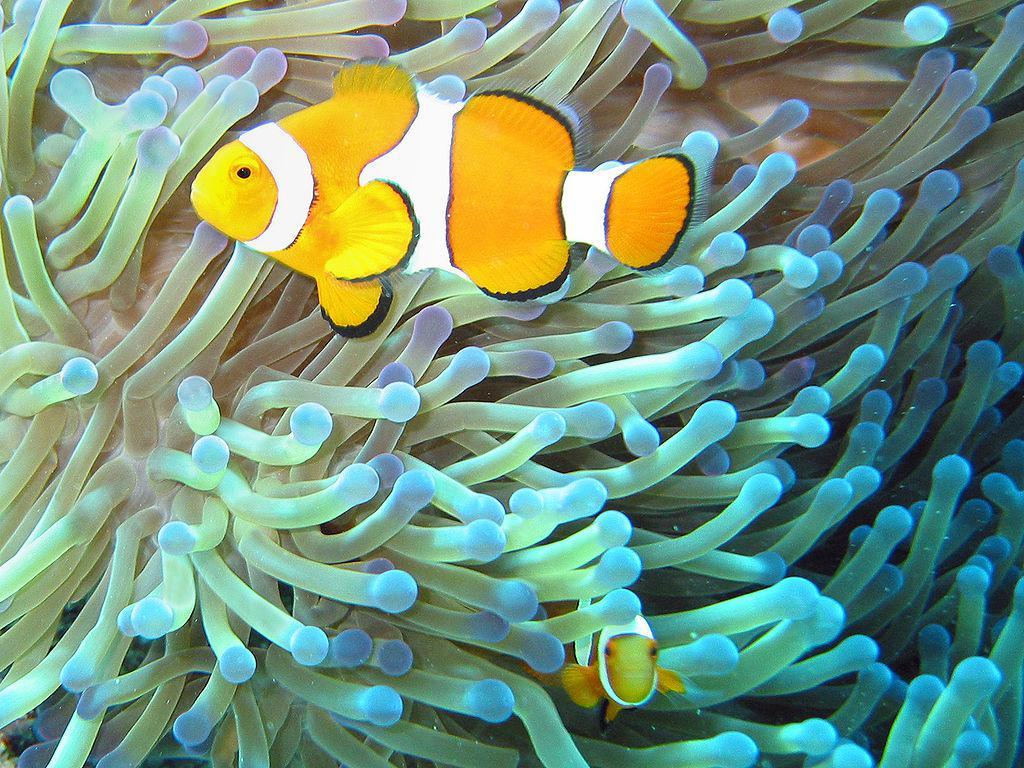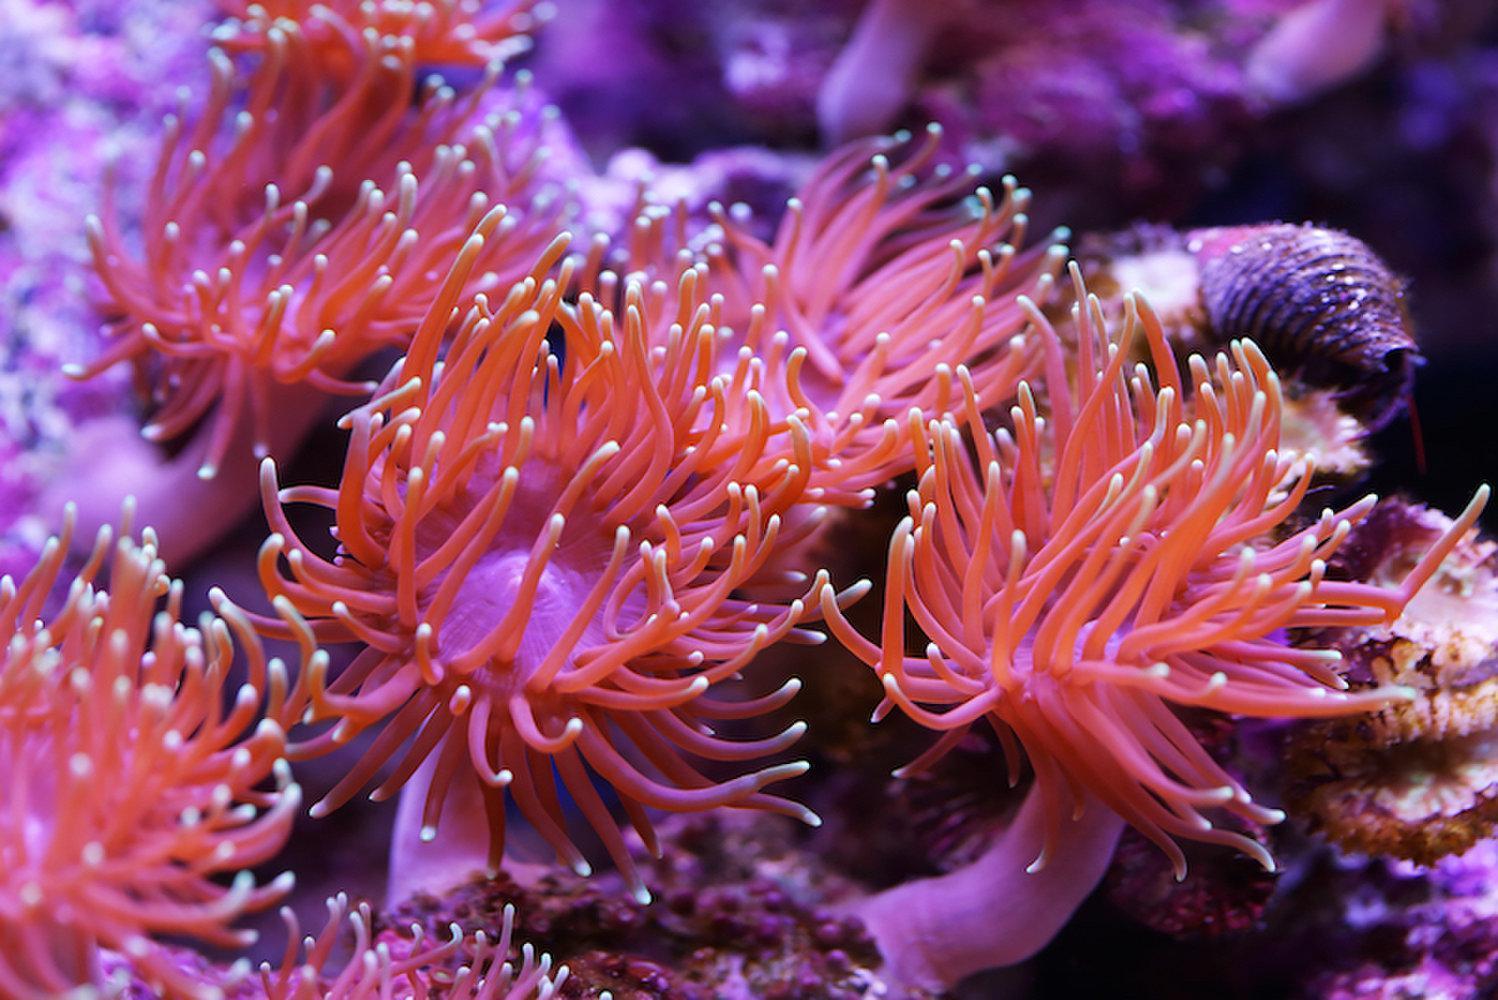The first image is the image on the left, the second image is the image on the right. For the images displayed, is the sentence "In both images the fish are near the sea anemone" factually correct? Answer yes or no. No. 